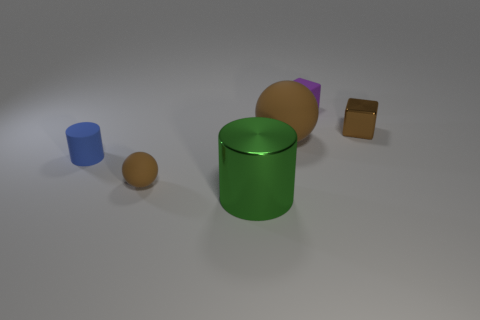What can you infer about the lighting in this scene? The lighting in the scene seems to be coming from above, casting soft shadows directly underneath the objects. The diffuse lighting suggests an indoor setup, likely with overhead artificial lighting that is neither too bright nor too dim. 